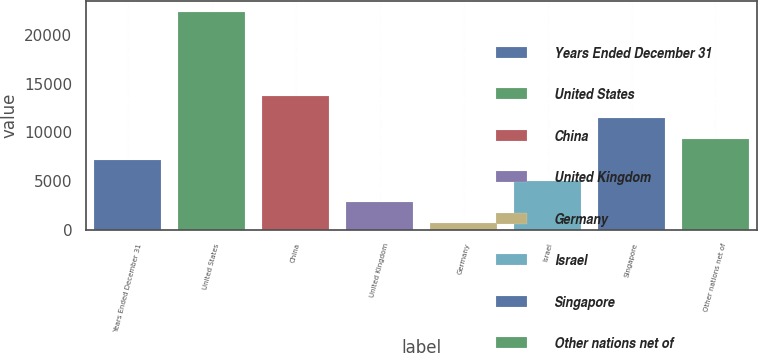<chart> <loc_0><loc_0><loc_500><loc_500><bar_chart><fcel>Years Ended December 31<fcel>United States<fcel>China<fcel>United Kingdom<fcel>Germany<fcel>Israel<fcel>Singapore<fcel>Other nations net of<nl><fcel>7166.3<fcel>22385<fcel>13688.6<fcel>2818.1<fcel>644<fcel>4992.2<fcel>11514.5<fcel>9340.4<nl></chart> 